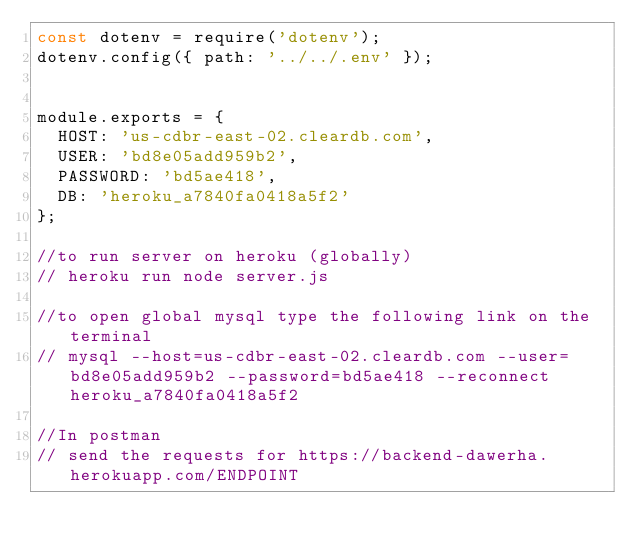<code> <loc_0><loc_0><loc_500><loc_500><_JavaScript_>const dotenv = require('dotenv');
dotenv.config({ path: '../../.env' });

 
module.exports = {
  HOST: 'us-cdbr-east-02.cleardb.com',
  USER: 'bd8e05add959b2',
  PASSWORD: 'bd5ae418',
  DB: 'heroku_a7840fa0418a5f2'
};

//to run server on heroku (globally)
// heroku run node server.js

//to open global mysql type the following link on the terminal 
// mysql --host=us-cdbr-east-02.cleardb.com --user=bd8e05add959b2 --password=bd5ae418 --reconnect heroku_a7840fa0418a5f2

//In postman
// send the requests for https://backend-dawerha.herokuapp.com/ENDPOINT</code> 